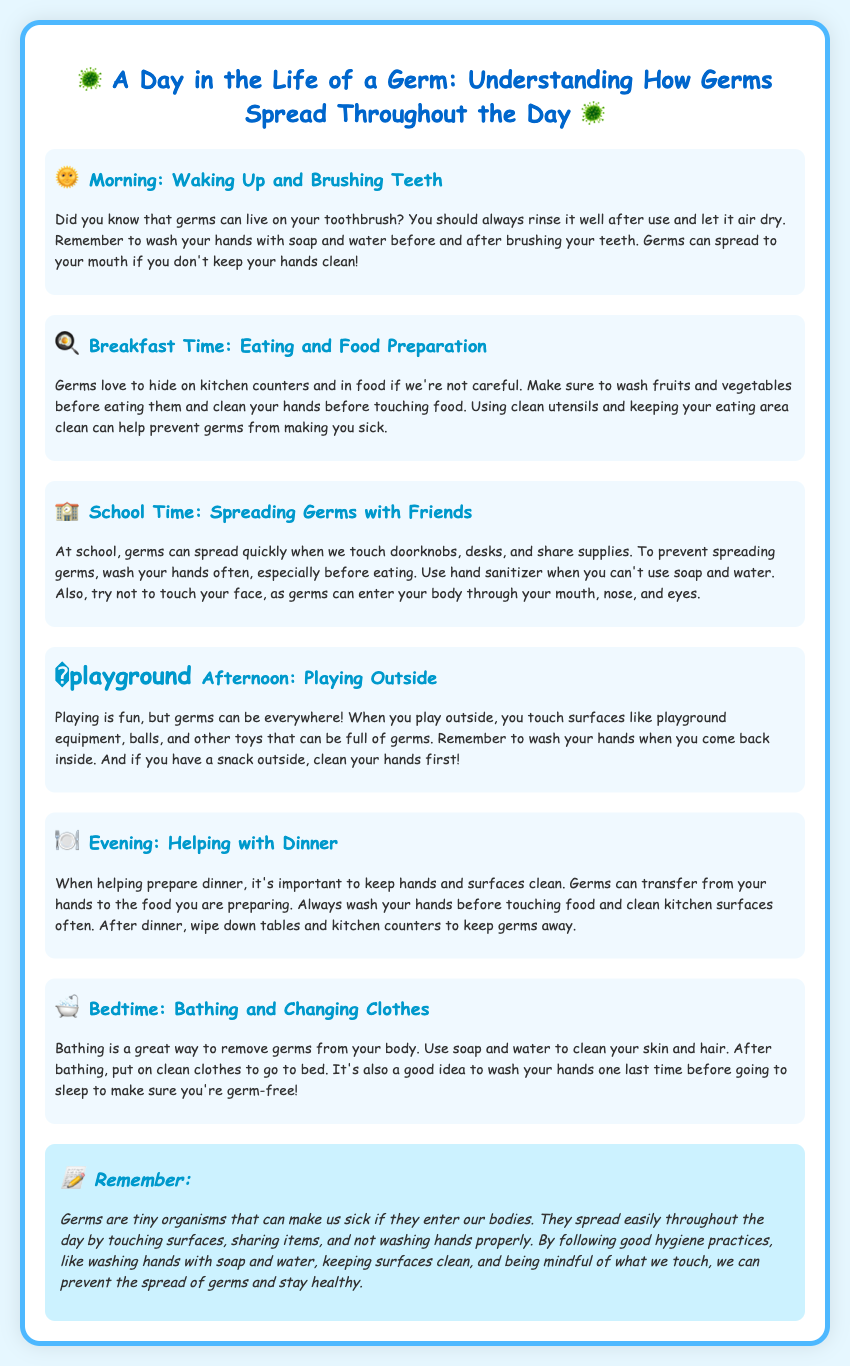What should you do after brushing your teeth? The document suggests rinsing your toothbrush well after use and letting it air dry. It also emphasizes washing hands with soap and water before and after brushing.
Answer: Rinse your toothbrush and wash your hands Where do germs love to hide during breakfast? The document states that germs love to hide on kitchen counters and in food if we're not careful.
Answer: Kitchen counters and in food What can prevent germs from spreading at school? The document mentions washing hands often, especially before eating, and using hand sanitizer when soap and water aren't available.
Answer: Wash hands and use hand sanitizer Which area should you wash your hands after playing outside? The document specifies that you should wash your hands when you come back inside from playing outside.
Answer: Wash hands when you come back inside What is a good hygiene practice before preparing dinner? According to the document, it’s important to wash your hands before touching food to prevent germs from transferring to the food.
Answer: Wash your hands What should you do with your toothbrush to keep germs away? The document indicates that you should always rinse your toothbrush well after use and let it air dry.
Answer: Rinse it well and let it air dry What is mentioned as a great way to remove germs from your body? The document highlights that bathing is a great way to remove germs.
Answer: Bathing What is one reason germs can enter your body? The document states that germs can enter the body through the mouth, nose, and eyes.
Answer: Mouth, nose, and eyes 